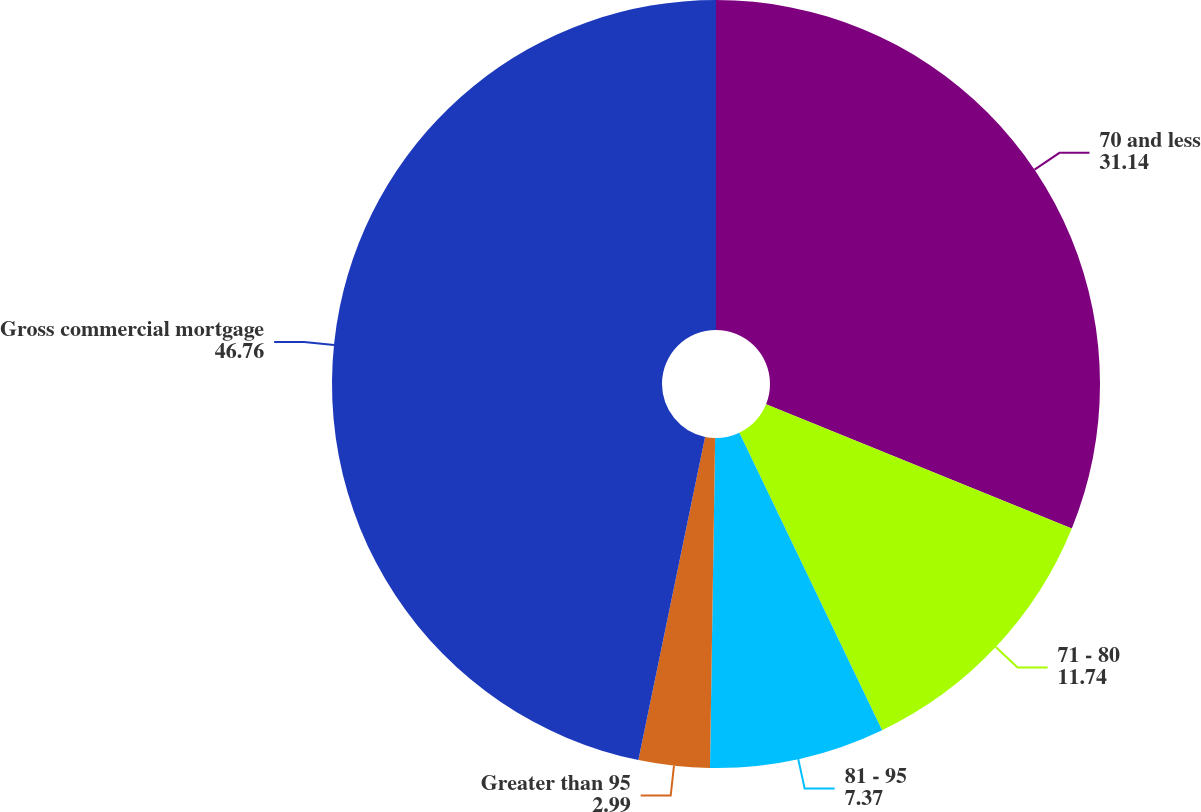Convert chart. <chart><loc_0><loc_0><loc_500><loc_500><pie_chart><fcel>70 and less<fcel>71 - 80<fcel>81 - 95<fcel>Greater than 95<fcel>Gross commercial mortgage<nl><fcel>31.14%<fcel>11.74%<fcel>7.37%<fcel>2.99%<fcel>46.76%<nl></chart> 